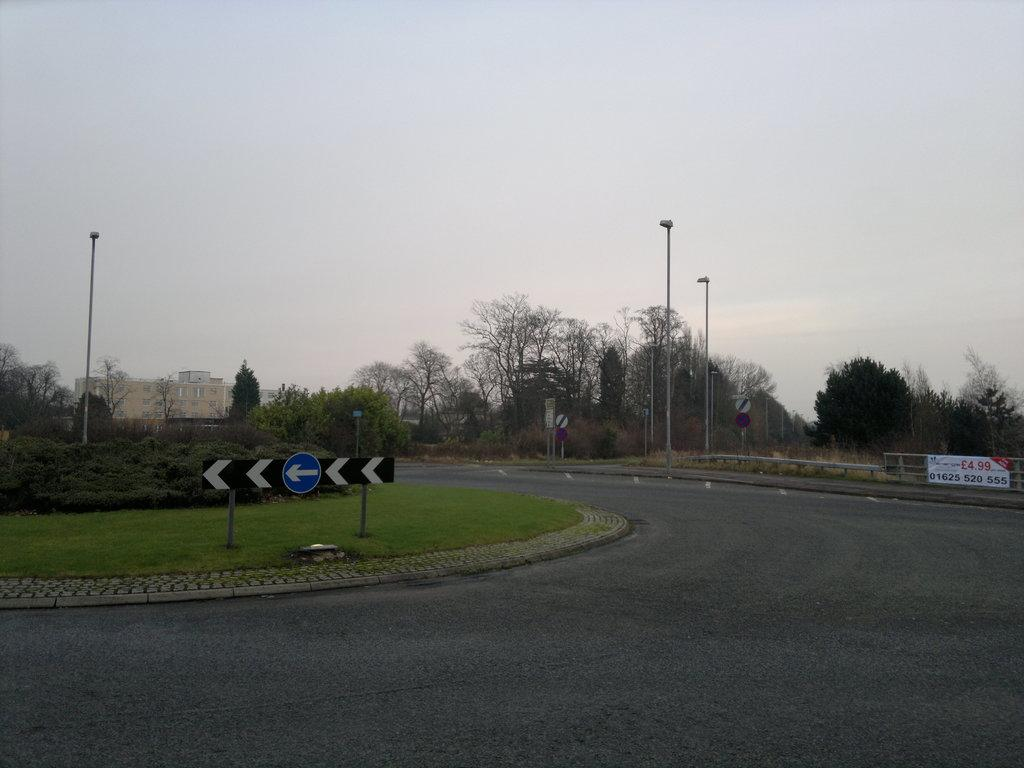What type of vegetation can be seen in the image? There are trees in the image. What structures are present in the image? There are poles, signboards, a building, and a banner in the image. What is the color of the sky in the image? The sky is blue and white in color. How many people are present in the crowd in the image? There is no crowd present in the image; it features trees, poles, signboards, a building, and a banner. What route is being followed by the paper in the image? There is no paper present in the image. 